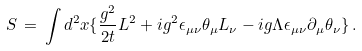<formula> <loc_0><loc_0><loc_500><loc_500>S \, = \, \int d ^ { 2 } x \{ \frac { g ^ { 2 } } { 2 t } L ^ { 2 } + i g ^ { 2 } \epsilon _ { \mu \nu } \theta _ { \mu } L _ { \nu } - i g \Lambda \epsilon _ { \mu \nu } \partial _ { \mu } \theta _ { \nu } \} \, .</formula> 